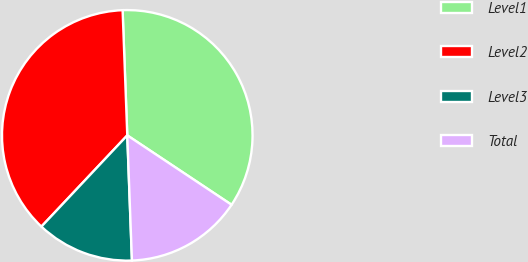Convert chart to OTSL. <chart><loc_0><loc_0><loc_500><loc_500><pie_chart><fcel>Level1<fcel>Level2<fcel>Level3<fcel>Total<nl><fcel>34.94%<fcel>37.39%<fcel>12.61%<fcel>15.06%<nl></chart> 